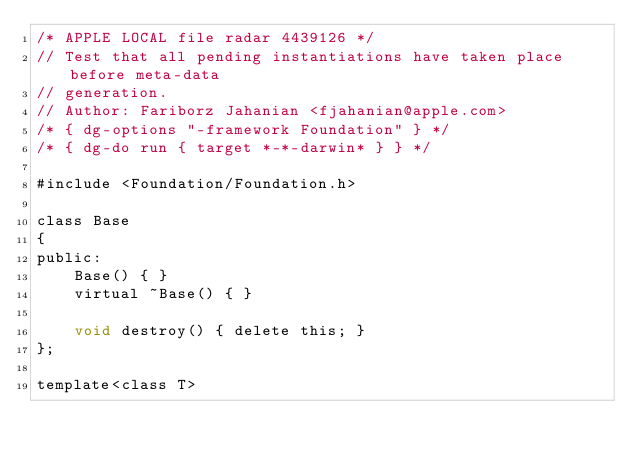Convert code to text. <code><loc_0><loc_0><loc_500><loc_500><_ObjectiveC_>/* APPLE LOCAL file radar 4439126 */
// Test that all pending instantiations have taken place before meta-data
// generation.
// Author: Fariborz Jahanian <fjahanian@apple.com>
/* { dg-options "-framework Foundation" } */
/* { dg-do run { target *-*-darwin* } } */

#include <Foundation/Foundation.h>

class Base
{
public:
	Base() { }
	virtual ~Base() { }
	
	void destroy() { delete this; }
};

template<class T></code> 